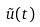<formula> <loc_0><loc_0><loc_500><loc_500>\tilde { u } ( t )</formula> 